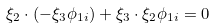Convert formula to latex. <formula><loc_0><loc_0><loc_500><loc_500>\xi _ { 2 } \cdot ( - \xi _ { 3 } \phi _ { 1 i } ) + \xi _ { 3 } \cdot \xi _ { 2 } \phi _ { 1 i } = 0</formula> 